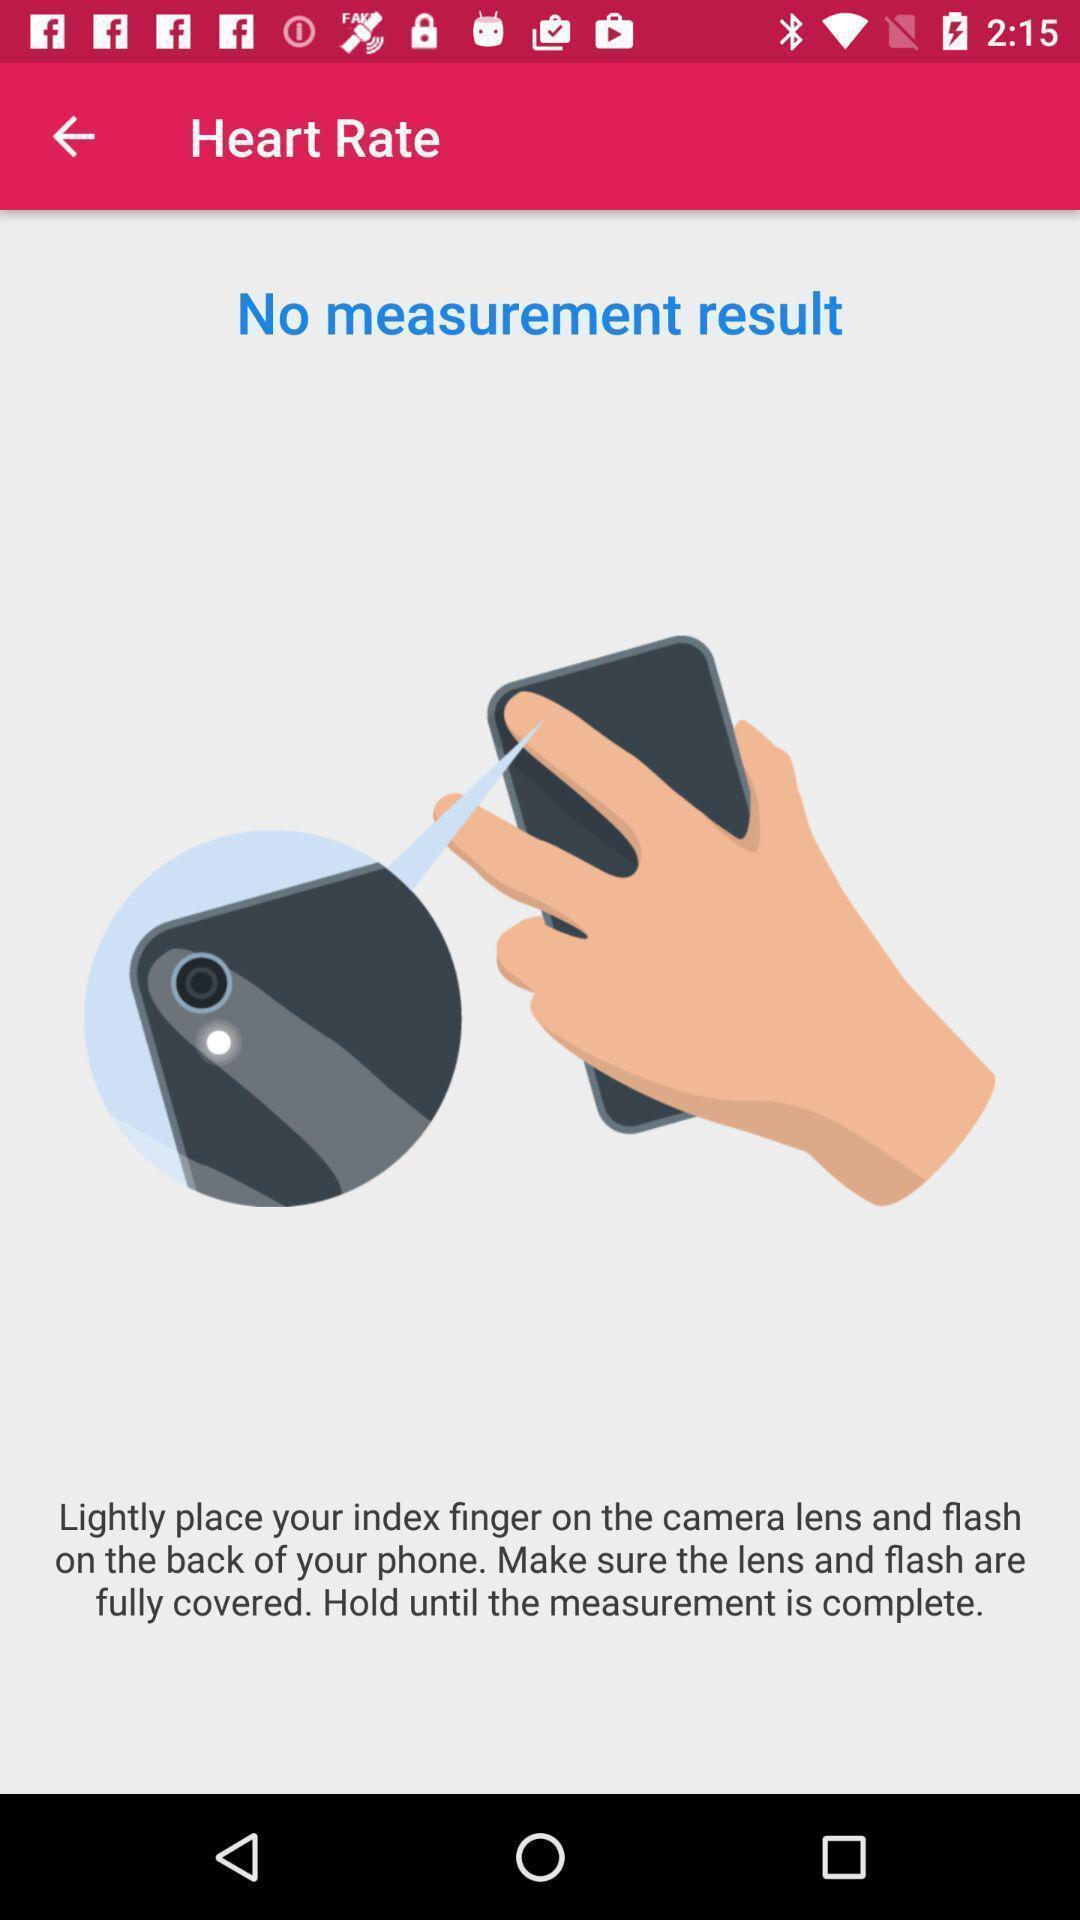What can you discern from this picture? Screen showing no measurement result. 